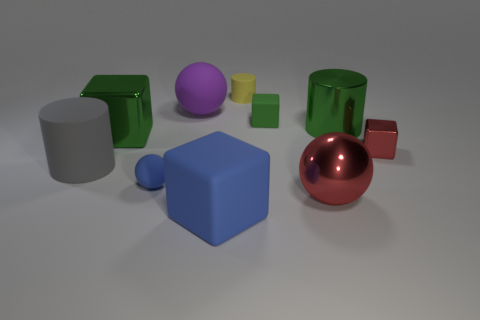Subtract all large balls. How many balls are left? 1 Subtract 2 cubes. How many cubes are left? 2 Subtract all blue blocks. How many blocks are left? 3 Subtract all cylinders. How many objects are left? 7 Subtract all cyan blocks. Subtract all yellow balls. How many blocks are left? 4 Add 10 yellow metal blocks. How many yellow metal blocks exist? 10 Subtract 1 green cylinders. How many objects are left? 9 Subtract all tiny matte cubes. Subtract all small purple metal balls. How many objects are left? 9 Add 4 gray matte cylinders. How many gray matte cylinders are left? 5 